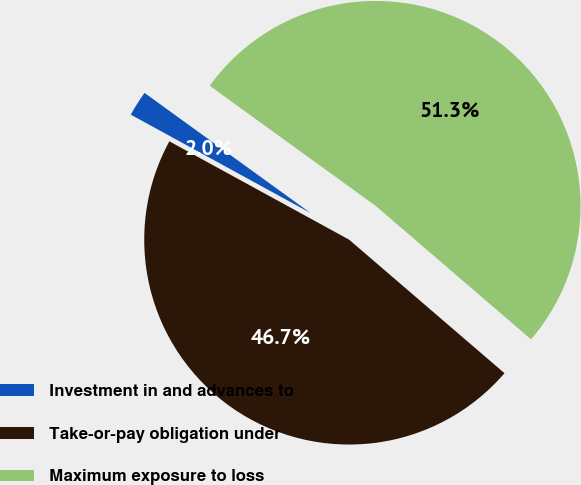Convert chart. <chart><loc_0><loc_0><loc_500><loc_500><pie_chart><fcel>Investment in and advances to<fcel>Take-or-pay obligation under<fcel>Maximum exposure to loss<nl><fcel>2.0%<fcel>46.67%<fcel>51.33%<nl></chart> 